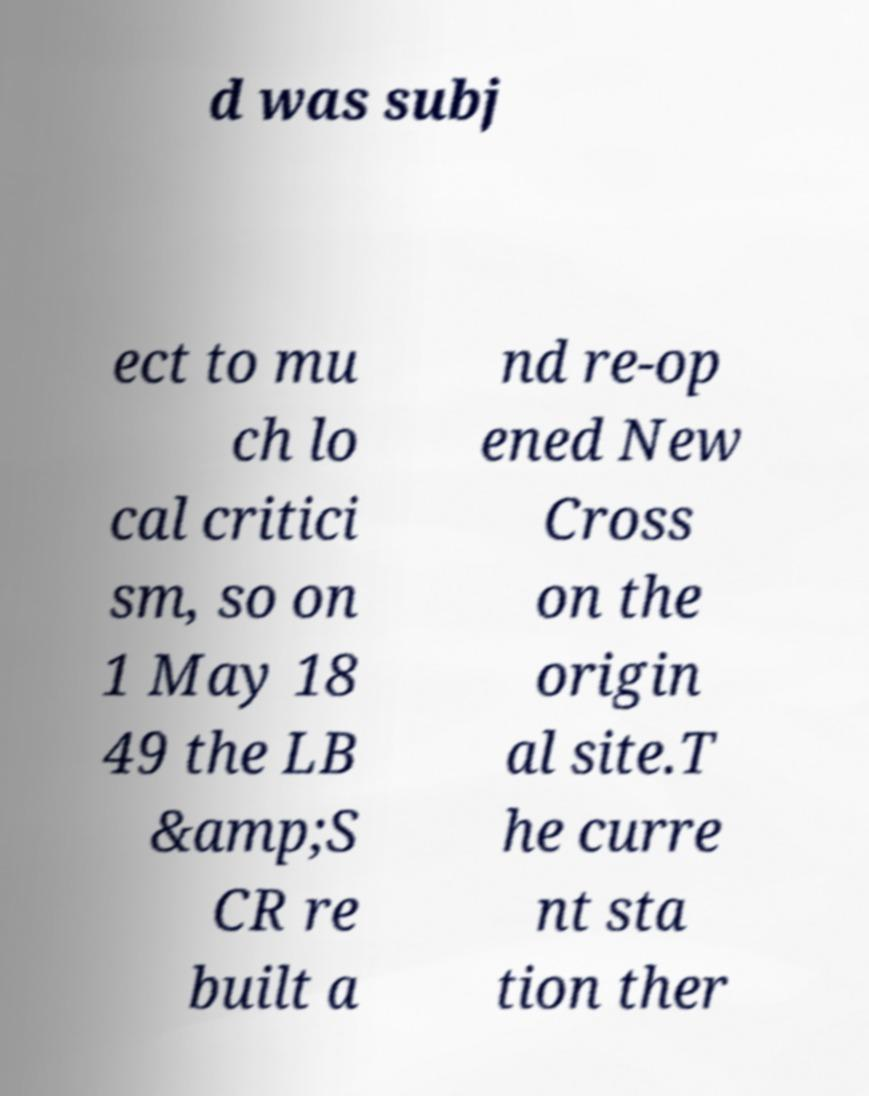Can you accurately transcribe the text from the provided image for me? d was subj ect to mu ch lo cal critici sm, so on 1 May 18 49 the LB &amp;S CR re built a nd re-op ened New Cross on the origin al site.T he curre nt sta tion ther 